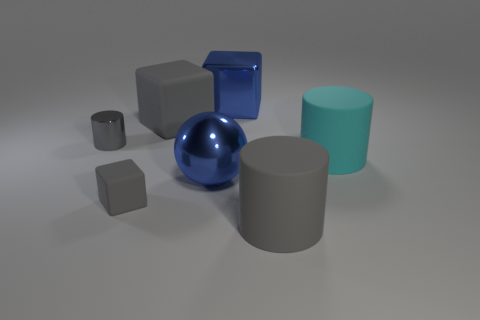Add 1 tiny gray things. How many objects exist? 8 Subtract all cubes. How many objects are left? 4 Subtract all tiny purple metal objects. Subtract all gray rubber cubes. How many objects are left? 5 Add 7 small shiny objects. How many small shiny objects are left? 8 Add 1 large cyan cylinders. How many large cyan cylinders exist? 2 Subtract 0 yellow blocks. How many objects are left? 7 